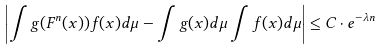<formula> <loc_0><loc_0><loc_500><loc_500>\left | \int g ( F ^ { n } ( x ) ) f ( x ) d \mu - \int g ( x ) d \mu \int f ( x ) d \mu \right | \leq C \cdot e ^ { - \lambda n }</formula> 